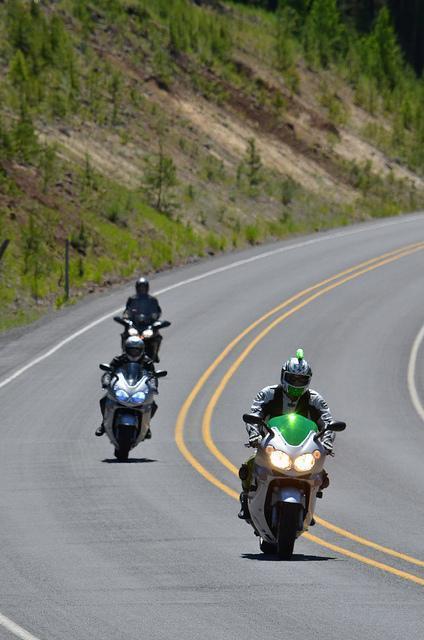How many lights are on the front of each motorcycle?
Give a very brief answer. 2. How many motorcycles are in the photo?
Give a very brief answer. 2. 